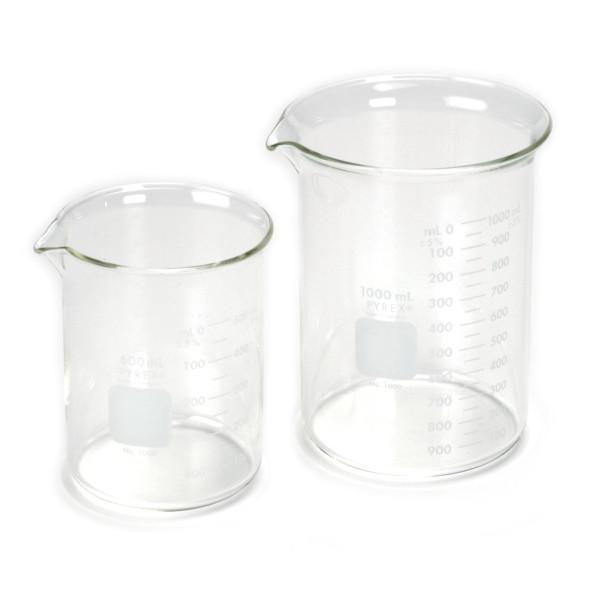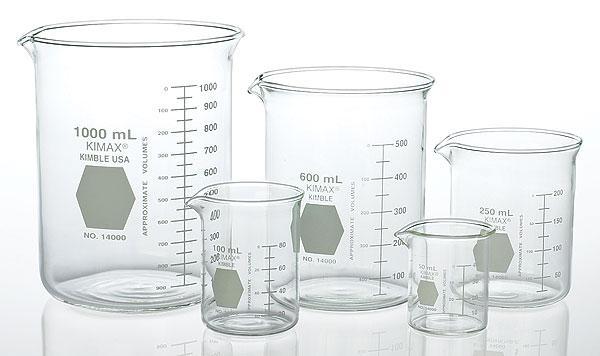The first image is the image on the left, the second image is the image on the right. For the images shown, is this caption "Exactly eight clear empty beakers are divided into two groupings, one with five beakers of different sizes and the other with three of different sizes." true? Answer yes or no. No. The first image is the image on the left, the second image is the image on the right. Analyze the images presented: Is the assertion "An image contains exactly three empty measuring cups, which are arranged in one horizontal row." valid? Answer yes or no. No. 